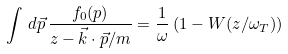Convert formula to latex. <formula><loc_0><loc_0><loc_500><loc_500>\int \, d \vec { p } \, \frac { f _ { 0 } ( p ) } { z - \vec { k } \cdot \vec { p } / m } = \frac { 1 } { \omega } \left ( 1 - { W } ( z / \omega _ { T } ) \right )</formula> 